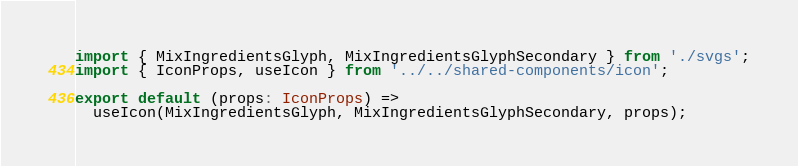<code> <loc_0><loc_0><loc_500><loc_500><_TypeScript_>import { MixIngredientsGlyph, MixIngredientsGlyphSecondary } from './svgs';
import { IconProps, useIcon } from '../../shared-components/icon';

export default (props: IconProps) =>
  useIcon(MixIngredientsGlyph, MixIngredientsGlyphSecondary, props);
</code> 